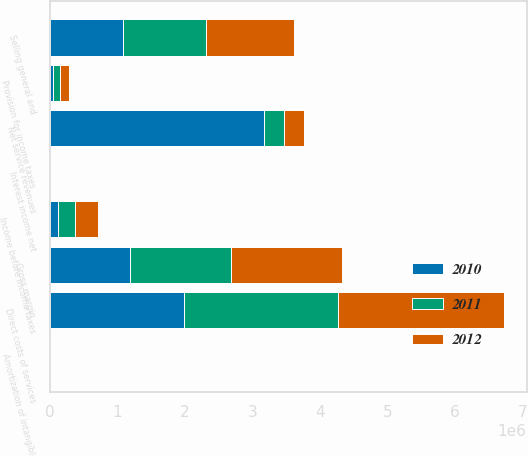Convert chart to OTSL. <chart><loc_0><loc_0><loc_500><loc_500><stacked_bar_chart><ecel><fcel>Net service revenues<fcel>Direct costs of services<fcel>Gross margin<fcel>Selling general and<fcel>Amortization of intangible<fcel>Interest income net<fcel>Income before income taxes<fcel>Provision for income taxes<nl><fcel>2012<fcel>297230<fcel>2.46215e+06<fcel>1.64906e+06<fcel>1.30561e+06<fcel>398<fcel>1197<fcel>344245<fcel>134303<nl><fcel>2011<fcel>297230<fcel>2.28737e+06<fcel>1.4896e+06<fcel>1.24018e+06<fcel>153<fcel>951<fcel>250216<fcel>100294<nl><fcel>2010<fcel>3.17509e+06<fcel>1.98106e+06<fcel>1.19403e+06<fcel>1.07903e+06<fcel>411<fcel>579<fcel>115168<fcel>49099<nl></chart> 